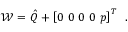<formula> <loc_0><loc_0><loc_500><loc_500>\mathcal { W } = \hat { Q } + \left [ 0 \, 0 \, 0 \, 0 \, p \right ] ^ { T } \, .</formula> 